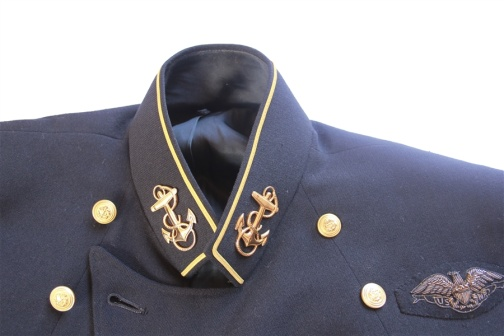Create a poetic description of the jacket, capturing its essence and mystery. Bound in the depths of midnight navy hue, 
A jacket, where stories of valor accrue. 
Golden threads, like whispers of time, 
Etch the tales of rank in delicate line. 
Anchors and eagles, emblems of might, 
Gleam in the shadows, catching the light. 
The collar stands tall, with regal grace, 
Guarding the secrets of a storied place. 
Buttons glisten like medals earned, 
Honoring lessons fiercely learned. 
Draped on unseen shoulders broad, 
It whispers of duty and laws untrod. 
A silent witness to history's drift, 
This jacket bears the freedom's gift. What role do you think this jacket played in its owner's life? This jacket likely played a central role in its owner’s life, symbolizing their status and achievements within the military hierarchy. Beyond its functional use, it would have been a source of pride and identity, marking their authority and commitment to duty. Each morning, upon donning the jacket, the wearer would be reminded of their responsibilities and the weight of their decisions. It would accompany them through strategic discussions, ceremonial duties, and perhaps even in moments of silent reflection before a battle. In essence, the jacket was more than just clothing; it was a testament to their life's work and their enduring legacy. 